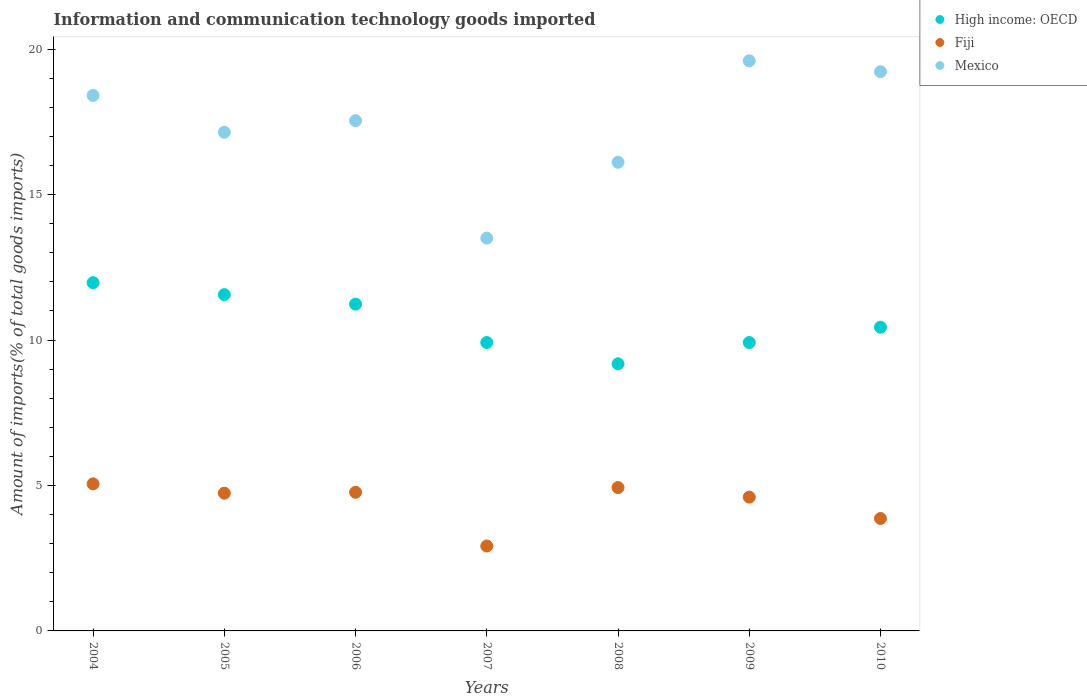Is the number of dotlines equal to the number of legend labels?
Provide a succinct answer. Yes. What is the amount of goods imported in High income: OECD in 2006?
Make the answer very short. 11.24. Across all years, what is the maximum amount of goods imported in Mexico?
Provide a short and direct response. 19.6. Across all years, what is the minimum amount of goods imported in Mexico?
Provide a succinct answer. 13.51. In which year was the amount of goods imported in Fiji maximum?
Your answer should be very brief. 2004. In which year was the amount of goods imported in Fiji minimum?
Give a very brief answer. 2007. What is the total amount of goods imported in High income: OECD in the graph?
Give a very brief answer. 74.23. What is the difference between the amount of goods imported in Mexico in 2005 and that in 2010?
Provide a succinct answer. -2.08. What is the difference between the amount of goods imported in High income: OECD in 2006 and the amount of goods imported in Mexico in 2008?
Your answer should be very brief. -4.88. What is the average amount of goods imported in Mexico per year?
Your answer should be very brief. 17.36. In the year 2007, what is the difference between the amount of goods imported in Fiji and amount of goods imported in High income: OECD?
Keep it short and to the point. -7. In how many years, is the amount of goods imported in High income: OECD greater than 18 %?
Keep it short and to the point. 0. What is the ratio of the amount of goods imported in Fiji in 2004 to that in 2009?
Give a very brief answer. 1.1. Is the difference between the amount of goods imported in Fiji in 2004 and 2010 greater than the difference between the amount of goods imported in High income: OECD in 2004 and 2010?
Ensure brevity in your answer.  No. What is the difference between the highest and the second highest amount of goods imported in Fiji?
Keep it short and to the point. 0.13. What is the difference between the highest and the lowest amount of goods imported in High income: OECD?
Ensure brevity in your answer.  2.79. In how many years, is the amount of goods imported in High income: OECD greater than the average amount of goods imported in High income: OECD taken over all years?
Offer a very short reply. 3. Is the sum of the amount of goods imported in Mexico in 2007 and 2009 greater than the maximum amount of goods imported in High income: OECD across all years?
Make the answer very short. Yes. Is it the case that in every year, the sum of the amount of goods imported in Fiji and amount of goods imported in High income: OECD  is greater than the amount of goods imported in Mexico?
Your answer should be compact. No. Is the amount of goods imported in Fiji strictly less than the amount of goods imported in Mexico over the years?
Your answer should be compact. Yes. Does the graph contain any zero values?
Keep it short and to the point. No. Where does the legend appear in the graph?
Offer a terse response. Top right. How many legend labels are there?
Make the answer very short. 3. How are the legend labels stacked?
Ensure brevity in your answer.  Vertical. What is the title of the graph?
Make the answer very short. Information and communication technology goods imported. What is the label or title of the Y-axis?
Provide a short and direct response. Amount of imports(% of total goods imports). What is the Amount of imports(% of total goods imports) in High income: OECD in 2004?
Your response must be concise. 11.97. What is the Amount of imports(% of total goods imports) of Fiji in 2004?
Your answer should be very brief. 5.06. What is the Amount of imports(% of total goods imports) of Mexico in 2004?
Give a very brief answer. 18.41. What is the Amount of imports(% of total goods imports) of High income: OECD in 2005?
Your answer should be very brief. 11.56. What is the Amount of imports(% of total goods imports) of Fiji in 2005?
Offer a terse response. 4.73. What is the Amount of imports(% of total goods imports) in Mexico in 2005?
Ensure brevity in your answer.  17.14. What is the Amount of imports(% of total goods imports) in High income: OECD in 2006?
Offer a very short reply. 11.24. What is the Amount of imports(% of total goods imports) in Fiji in 2006?
Offer a terse response. 4.77. What is the Amount of imports(% of total goods imports) in Mexico in 2006?
Your answer should be very brief. 17.54. What is the Amount of imports(% of total goods imports) in High income: OECD in 2007?
Provide a succinct answer. 9.92. What is the Amount of imports(% of total goods imports) of Fiji in 2007?
Offer a very short reply. 2.92. What is the Amount of imports(% of total goods imports) of Mexico in 2007?
Your answer should be compact. 13.51. What is the Amount of imports(% of total goods imports) in High income: OECD in 2008?
Provide a short and direct response. 9.18. What is the Amount of imports(% of total goods imports) in Fiji in 2008?
Your response must be concise. 4.93. What is the Amount of imports(% of total goods imports) of Mexico in 2008?
Provide a short and direct response. 16.11. What is the Amount of imports(% of total goods imports) in High income: OECD in 2009?
Your response must be concise. 9.92. What is the Amount of imports(% of total goods imports) of Fiji in 2009?
Provide a succinct answer. 4.6. What is the Amount of imports(% of total goods imports) of Mexico in 2009?
Keep it short and to the point. 19.6. What is the Amount of imports(% of total goods imports) of High income: OECD in 2010?
Make the answer very short. 10.44. What is the Amount of imports(% of total goods imports) in Fiji in 2010?
Your answer should be compact. 3.87. What is the Amount of imports(% of total goods imports) of Mexico in 2010?
Your answer should be very brief. 19.23. Across all years, what is the maximum Amount of imports(% of total goods imports) of High income: OECD?
Your response must be concise. 11.97. Across all years, what is the maximum Amount of imports(% of total goods imports) in Fiji?
Offer a terse response. 5.06. Across all years, what is the maximum Amount of imports(% of total goods imports) of Mexico?
Offer a terse response. 19.6. Across all years, what is the minimum Amount of imports(% of total goods imports) of High income: OECD?
Your response must be concise. 9.18. Across all years, what is the minimum Amount of imports(% of total goods imports) of Fiji?
Ensure brevity in your answer.  2.92. Across all years, what is the minimum Amount of imports(% of total goods imports) in Mexico?
Offer a very short reply. 13.51. What is the total Amount of imports(% of total goods imports) of High income: OECD in the graph?
Make the answer very short. 74.23. What is the total Amount of imports(% of total goods imports) of Fiji in the graph?
Your answer should be very brief. 30.87. What is the total Amount of imports(% of total goods imports) in Mexico in the graph?
Your answer should be compact. 121.54. What is the difference between the Amount of imports(% of total goods imports) in High income: OECD in 2004 and that in 2005?
Keep it short and to the point. 0.41. What is the difference between the Amount of imports(% of total goods imports) in Fiji in 2004 and that in 2005?
Your answer should be compact. 0.32. What is the difference between the Amount of imports(% of total goods imports) in Mexico in 2004 and that in 2005?
Ensure brevity in your answer.  1.27. What is the difference between the Amount of imports(% of total goods imports) in High income: OECD in 2004 and that in 2006?
Your answer should be compact. 0.74. What is the difference between the Amount of imports(% of total goods imports) in Fiji in 2004 and that in 2006?
Your answer should be compact. 0.29. What is the difference between the Amount of imports(% of total goods imports) of Mexico in 2004 and that in 2006?
Give a very brief answer. 0.87. What is the difference between the Amount of imports(% of total goods imports) in High income: OECD in 2004 and that in 2007?
Offer a terse response. 2.06. What is the difference between the Amount of imports(% of total goods imports) of Fiji in 2004 and that in 2007?
Your response must be concise. 2.14. What is the difference between the Amount of imports(% of total goods imports) in Mexico in 2004 and that in 2007?
Offer a very short reply. 4.9. What is the difference between the Amount of imports(% of total goods imports) of High income: OECD in 2004 and that in 2008?
Offer a very short reply. 2.79. What is the difference between the Amount of imports(% of total goods imports) in Fiji in 2004 and that in 2008?
Ensure brevity in your answer.  0.13. What is the difference between the Amount of imports(% of total goods imports) of Mexico in 2004 and that in 2008?
Make the answer very short. 2.3. What is the difference between the Amount of imports(% of total goods imports) of High income: OECD in 2004 and that in 2009?
Your response must be concise. 2.06. What is the difference between the Amount of imports(% of total goods imports) of Fiji in 2004 and that in 2009?
Your response must be concise. 0.46. What is the difference between the Amount of imports(% of total goods imports) of Mexico in 2004 and that in 2009?
Provide a short and direct response. -1.19. What is the difference between the Amount of imports(% of total goods imports) of High income: OECD in 2004 and that in 2010?
Offer a terse response. 1.53. What is the difference between the Amount of imports(% of total goods imports) in Fiji in 2004 and that in 2010?
Provide a short and direct response. 1.19. What is the difference between the Amount of imports(% of total goods imports) in Mexico in 2004 and that in 2010?
Offer a very short reply. -0.82. What is the difference between the Amount of imports(% of total goods imports) in High income: OECD in 2005 and that in 2006?
Offer a very short reply. 0.33. What is the difference between the Amount of imports(% of total goods imports) of Fiji in 2005 and that in 2006?
Make the answer very short. -0.03. What is the difference between the Amount of imports(% of total goods imports) of Mexico in 2005 and that in 2006?
Make the answer very short. -0.4. What is the difference between the Amount of imports(% of total goods imports) of High income: OECD in 2005 and that in 2007?
Make the answer very short. 1.65. What is the difference between the Amount of imports(% of total goods imports) in Fiji in 2005 and that in 2007?
Ensure brevity in your answer.  1.82. What is the difference between the Amount of imports(% of total goods imports) of Mexico in 2005 and that in 2007?
Give a very brief answer. 3.64. What is the difference between the Amount of imports(% of total goods imports) in High income: OECD in 2005 and that in 2008?
Ensure brevity in your answer.  2.38. What is the difference between the Amount of imports(% of total goods imports) in Fiji in 2005 and that in 2008?
Offer a terse response. -0.19. What is the difference between the Amount of imports(% of total goods imports) in Mexico in 2005 and that in 2008?
Give a very brief answer. 1.03. What is the difference between the Amount of imports(% of total goods imports) in High income: OECD in 2005 and that in 2009?
Keep it short and to the point. 1.65. What is the difference between the Amount of imports(% of total goods imports) of Fiji in 2005 and that in 2009?
Offer a terse response. 0.13. What is the difference between the Amount of imports(% of total goods imports) of Mexico in 2005 and that in 2009?
Your answer should be compact. -2.46. What is the difference between the Amount of imports(% of total goods imports) of High income: OECD in 2005 and that in 2010?
Offer a terse response. 1.12. What is the difference between the Amount of imports(% of total goods imports) of Fiji in 2005 and that in 2010?
Offer a very short reply. 0.87. What is the difference between the Amount of imports(% of total goods imports) of Mexico in 2005 and that in 2010?
Your response must be concise. -2.08. What is the difference between the Amount of imports(% of total goods imports) of High income: OECD in 2006 and that in 2007?
Keep it short and to the point. 1.32. What is the difference between the Amount of imports(% of total goods imports) in Fiji in 2006 and that in 2007?
Provide a succinct answer. 1.85. What is the difference between the Amount of imports(% of total goods imports) of Mexico in 2006 and that in 2007?
Offer a very short reply. 4.04. What is the difference between the Amount of imports(% of total goods imports) in High income: OECD in 2006 and that in 2008?
Offer a terse response. 2.05. What is the difference between the Amount of imports(% of total goods imports) of Fiji in 2006 and that in 2008?
Give a very brief answer. -0.16. What is the difference between the Amount of imports(% of total goods imports) in Mexico in 2006 and that in 2008?
Provide a short and direct response. 1.43. What is the difference between the Amount of imports(% of total goods imports) in High income: OECD in 2006 and that in 2009?
Your response must be concise. 1.32. What is the difference between the Amount of imports(% of total goods imports) in Fiji in 2006 and that in 2009?
Give a very brief answer. 0.17. What is the difference between the Amount of imports(% of total goods imports) in Mexico in 2006 and that in 2009?
Offer a very short reply. -2.06. What is the difference between the Amount of imports(% of total goods imports) of High income: OECD in 2006 and that in 2010?
Make the answer very short. 0.79. What is the difference between the Amount of imports(% of total goods imports) of Fiji in 2006 and that in 2010?
Your answer should be compact. 0.9. What is the difference between the Amount of imports(% of total goods imports) of Mexico in 2006 and that in 2010?
Your answer should be compact. -1.68. What is the difference between the Amount of imports(% of total goods imports) in High income: OECD in 2007 and that in 2008?
Ensure brevity in your answer.  0.73. What is the difference between the Amount of imports(% of total goods imports) of Fiji in 2007 and that in 2008?
Your answer should be very brief. -2.01. What is the difference between the Amount of imports(% of total goods imports) in Mexico in 2007 and that in 2008?
Give a very brief answer. -2.61. What is the difference between the Amount of imports(% of total goods imports) of High income: OECD in 2007 and that in 2009?
Give a very brief answer. 0. What is the difference between the Amount of imports(% of total goods imports) in Fiji in 2007 and that in 2009?
Ensure brevity in your answer.  -1.68. What is the difference between the Amount of imports(% of total goods imports) in Mexico in 2007 and that in 2009?
Make the answer very short. -6.09. What is the difference between the Amount of imports(% of total goods imports) in High income: OECD in 2007 and that in 2010?
Your response must be concise. -0.53. What is the difference between the Amount of imports(% of total goods imports) of Fiji in 2007 and that in 2010?
Ensure brevity in your answer.  -0.95. What is the difference between the Amount of imports(% of total goods imports) in Mexico in 2007 and that in 2010?
Offer a very short reply. -5.72. What is the difference between the Amount of imports(% of total goods imports) of High income: OECD in 2008 and that in 2009?
Ensure brevity in your answer.  -0.73. What is the difference between the Amount of imports(% of total goods imports) of Fiji in 2008 and that in 2009?
Offer a terse response. 0.33. What is the difference between the Amount of imports(% of total goods imports) of Mexico in 2008 and that in 2009?
Provide a succinct answer. -3.49. What is the difference between the Amount of imports(% of total goods imports) in High income: OECD in 2008 and that in 2010?
Provide a succinct answer. -1.26. What is the difference between the Amount of imports(% of total goods imports) in Fiji in 2008 and that in 2010?
Give a very brief answer. 1.06. What is the difference between the Amount of imports(% of total goods imports) of Mexico in 2008 and that in 2010?
Your response must be concise. -3.11. What is the difference between the Amount of imports(% of total goods imports) in High income: OECD in 2009 and that in 2010?
Your response must be concise. -0.53. What is the difference between the Amount of imports(% of total goods imports) of Fiji in 2009 and that in 2010?
Keep it short and to the point. 0.73. What is the difference between the Amount of imports(% of total goods imports) of Mexico in 2009 and that in 2010?
Offer a terse response. 0.37. What is the difference between the Amount of imports(% of total goods imports) of High income: OECD in 2004 and the Amount of imports(% of total goods imports) of Fiji in 2005?
Ensure brevity in your answer.  7.24. What is the difference between the Amount of imports(% of total goods imports) of High income: OECD in 2004 and the Amount of imports(% of total goods imports) of Mexico in 2005?
Your response must be concise. -5.17. What is the difference between the Amount of imports(% of total goods imports) in Fiji in 2004 and the Amount of imports(% of total goods imports) in Mexico in 2005?
Make the answer very short. -12.09. What is the difference between the Amount of imports(% of total goods imports) in High income: OECD in 2004 and the Amount of imports(% of total goods imports) in Fiji in 2006?
Provide a short and direct response. 7.21. What is the difference between the Amount of imports(% of total goods imports) of High income: OECD in 2004 and the Amount of imports(% of total goods imports) of Mexico in 2006?
Provide a short and direct response. -5.57. What is the difference between the Amount of imports(% of total goods imports) of Fiji in 2004 and the Amount of imports(% of total goods imports) of Mexico in 2006?
Offer a terse response. -12.49. What is the difference between the Amount of imports(% of total goods imports) in High income: OECD in 2004 and the Amount of imports(% of total goods imports) in Fiji in 2007?
Make the answer very short. 9.05. What is the difference between the Amount of imports(% of total goods imports) of High income: OECD in 2004 and the Amount of imports(% of total goods imports) of Mexico in 2007?
Keep it short and to the point. -1.53. What is the difference between the Amount of imports(% of total goods imports) of Fiji in 2004 and the Amount of imports(% of total goods imports) of Mexico in 2007?
Your response must be concise. -8.45. What is the difference between the Amount of imports(% of total goods imports) in High income: OECD in 2004 and the Amount of imports(% of total goods imports) in Fiji in 2008?
Provide a succinct answer. 7.04. What is the difference between the Amount of imports(% of total goods imports) of High income: OECD in 2004 and the Amount of imports(% of total goods imports) of Mexico in 2008?
Provide a short and direct response. -4.14. What is the difference between the Amount of imports(% of total goods imports) in Fiji in 2004 and the Amount of imports(% of total goods imports) in Mexico in 2008?
Provide a succinct answer. -11.06. What is the difference between the Amount of imports(% of total goods imports) in High income: OECD in 2004 and the Amount of imports(% of total goods imports) in Fiji in 2009?
Ensure brevity in your answer.  7.37. What is the difference between the Amount of imports(% of total goods imports) of High income: OECD in 2004 and the Amount of imports(% of total goods imports) of Mexico in 2009?
Keep it short and to the point. -7.63. What is the difference between the Amount of imports(% of total goods imports) of Fiji in 2004 and the Amount of imports(% of total goods imports) of Mexico in 2009?
Provide a short and direct response. -14.54. What is the difference between the Amount of imports(% of total goods imports) of High income: OECD in 2004 and the Amount of imports(% of total goods imports) of Fiji in 2010?
Ensure brevity in your answer.  8.11. What is the difference between the Amount of imports(% of total goods imports) in High income: OECD in 2004 and the Amount of imports(% of total goods imports) in Mexico in 2010?
Keep it short and to the point. -7.25. What is the difference between the Amount of imports(% of total goods imports) in Fiji in 2004 and the Amount of imports(% of total goods imports) in Mexico in 2010?
Your response must be concise. -14.17. What is the difference between the Amount of imports(% of total goods imports) of High income: OECD in 2005 and the Amount of imports(% of total goods imports) of Fiji in 2006?
Your response must be concise. 6.8. What is the difference between the Amount of imports(% of total goods imports) of High income: OECD in 2005 and the Amount of imports(% of total goods imports) of Mexico in 2006?
Give a very brief answer. -5.98. What is the difference between the Amount of imports(% of total goods imports) of Fiji in 2005 and the Amount of imports(% of total goods imports) of Mexico in 2006?
Ensure brevity in your answer.  -12.81. What is the difference between the Amount of imports(% of total goods imports) in High income: OECD in 2005 and the Amount of imports(% of total goods imports) in Fiji in 2007?
Provide a succinct answer. 8.64. What is the difference between the Amount of imports(% of total goods imports) of High income: OECD in 2005 and the Amount of imports(% of total goods imports) of Mexico in 2007?
Your response must be concise. -1.94. What is the difference between the Amount of imports(% of total goods imports) in Fiji in 2005 and the Amount of imports(% of total goods imports) in Mexico in 2007?
Provide a short and direct response. -8.77. What is the difference between the Amount of imports(% of total goods imports) in High income: OECD in 2005 and the Amount of imports(% of total goods imports) in Fiji in 2008?
Your answer should be very brief. 6.63. What is the difference between the Amount of imports(% of total goods imports) in High income: OECD in 2005 and the Amount of imports(% of total goods imports) in Mexico in 2008?
Your answer should be very brief. -4.55. What is the difference between the Amount of imports(% of total goods imports) of Fiji in 2005 and the Amount of imports(% of total goods imports) of Mexico in 2008?
Make the answer very short. -11.38. What is the difference between the Amount of imports(% of total goods imports) in High income: OECD in 2005 and the Amount of imports(% of total goods imports) in Fiji in 2009?
Make the answer very short. 6.96. What is the difference between the Amount of imports(% of total goods imports) in High income: OECD in 2005 and the Amount of imports(% of total goods imports) in Mexico in 2009?
Your answer should be compact. -8.04. What is the difference between the Amount of imports(% of total goods imports) in Fiji in 2005 and the Amount of imports(% of total goods imports) in Mexico in 2009?
Give a very brief answer. -14.86. What is the difference between the Amount of imports(% of total goods imports) of High income: OECD in 2005 and the Amount of imports(% of total goods imports) of Fiji in 2010?
Provide a succinct answer. 7.7. What is the difference between the Amount of imports(% of total goods imports) of High income: OECD in 2005 and the Amount of imports(% of total goods imports) of Mexico in 2010?
Provide a succinct answer. -7.66. What is the difference between the Amount of imports(% of total goods imports) of Fiji in 2005 and the Amount of imports(% of total goods imports) of Mexico in 2010?
Offer a very short reply. -14.49. What is the difference between the Amount of imports(% of total goods imports) in High income: OECD in 2006 and the Amount of imports(% of total goods imports) in Fiji in 2007?
Your answer should be compact. 8.32. What is the difference between the Amount of imports(% of total goods imports) of High income: OECD in 2006 and the Amount of imports(% of total goods imports) of Mexico in 2007?
Offer a terse response. -2.27. What is the difference between the Amount of imports(% of total goods imports) of Fiji in 2006 and the Amount of imports(% of total goods imports) of Mexico in 2007?
Offer a terse response. -8.74. What is the difference between the Amount of imports(% of total goods imports) of High income: OECD in 2006 and the Amount of imports(% of total goods imports) of Fiji in 2008?
Provide a short and direct response. 6.31. What is the difference between the Amount of imports(% of total goods imports) of High income: OECD in 2006 and the Amount of imports(% of total goods imports) of Mexico in 2008?
Offer a terse response. -4.88. What is the difference between the Amount of imports(% of total goods imports) in Fiji in 2006 and the Amount of imports(% of total goods imports) in Mexico in 2008?
Make the answer very short. -11.35. What is the difference between the Amount of imports(% of total goods imports) of High income: OECD in 2006 and the Amount of imports(% of total goods imports) of Fiji in 2009?
Provide a succinct answer. 6.63. What is the difference between the Amount of imports(% of total goods imports) of High income: OECD in 2006 and the Amount of imports(% of total goods imports) of Mexico in 2009?
Your answer should be compact. -8.36. What is the difference between the Amount of imports(% of total goods imports) of Fiji in 2006 and the Amount of imports(% of total goods imports) of Mexico in 2009?
Keep it short and to the point. -14.83. What is the difference between the Amount of imports(% of total goods imports) of High income: OECD in 2006 and the Amount of imports(% of total goods imports) of Fiji in 2010?
Keep it short and to the point. 7.37. What is the difference between the Amount of imports(% of total goods imports) of High income: OECD in 2006 and the Amount of imports(% of total goods imports) of Mexico in 2010?
Your response must be concise. -7.99. What is the difference between the Amount of imports(% of total goods imports) of Fiji in 2006 and the Amount of imports(% of total goods imports) of Mexico in 2010?
Give a very brief answer. -14.46. What is the difference between the Amount of imports(% of total goods imports) in High income: OECD in 2007 and the Amount of imports(% of total goods imports) in Fiji in 2008?
Your response must be concise. 4.99. What is the difference between the Amount of imports(% of total goods imports) of High income: OECD in 2007 and the Amount of imports(% of total goods imports) of Mexico in 2008?
Give a very brief answer. -6.2. What is the difference between the Amount of imports(% of total goods imports) in Fiji in 2007 and the Amount of imports(% of total goods imports) in Mexico in 2008?
Provide a succinct answer. -13.19. What is the difference between the Amount of imports(% of total goods imports) in High income: OECD in 2007 and the Amount of imports(% of total goods imports) in Fiji in 2009?
Your answer should be compact. 5.32. What is the difference between the Amount of imports(% of total goods imports) of High income: OECD in 2007 and the Amount of imports(% of total goods imports) of Mexico in 2009?
Your answer should be compact. -9.68. What is the difference between the Amount of imports(% of total goods imports) in Fiji in 2007 and the Amount of imports(% of total goods imports) in Mexico in 2009?
Your answer should be compact. -16.68. What is the difference between the Amount of imports(% of total goods imports) in High income: OECD in 2007 and the Amount of imports(% of total goods imports) in Fiji in 2010?
Your answer should be very brief. 6.05. What is the difference between the Amount of imports(% of total goods imports) in High income: OECD in 2007 and the Amount of imports(% of total goods imports) in Mexico in 2010?
Your answer should be very brief. -9.31. What is the difference between the Amount of imports(% of total goods imports) in Fiji in 2007 and the Amount of imports(% of total goods imports) in Mexico in 2010?
Your response must be concise. -16.31. What is the difference between the Amount of imports(% of total goods imports) in High income: OECD in 2008 and the Amount of imports(% of total goods imports) in Fiji in 2009?
Your answer should be very brief. 4.58. What is the difference between the Amount of imports(% of total goods imports) in High income: OECD in 2008 and the Amount of imports(% of total goods imports) in Mexico in 2009?
Your answer should be very brief. -10.42. What is the difference between the Amount of imports(% of total goods imports) in Fiji in 2008 and the Amount of imports(% of total goods imports) in Mexico in 2009?
Your answer should be very brief. -14.67. What is the difference between the Amount of imports(% of total goods imports) of High income: OECD in 2008 and the Amount of imports(% of total goods imports) of Fiji in 2010?
Provide a short and direct response. 5.32. What is the difference between the Amount of imports(% of total goods imports) in High income: OECD in 2008 and the Amount of imports(% of total goods imports) in Mexico in 2010?
Give a very brief answer. -10.04. What is the difference between the Amount of imports(% of total goods imports) of Fiji in 2008 and the Amount of imports(% of total goods imports) of Mexico in 2010?
Give a very brief answer. -14.3. What is the difference between the Amount of imports(% of total goods imports) in High income: OECD in 2009 and the Amount of imports(% of total goods imports) in Fiji in 2010?
Make the answer very short. 6.05. What is the difference between the Amount of imports(% of total goods imports) of High income: OECD in 2009 and the Amount of imports(% of total goods imports) of Mexico in 2010?
Ensure brevity in your answer.  -9.31. What is the difference between the Amount of imports(% of total goods imports) in Fiji in 2009 and the Amount of imports(% of total goods imports) in Mexico in 2010?
Ensure brevity in your answer.  -14.63. What is the average Amount of imports(% of total goods imports) of High income: OECD per year?
Offer a very short reply. 10.6. What is the average Amount of imports(% of total goods imports) in Fiji per year?
Offer a terse response. 4.41. What is the average Amount of imports(% of total goods imports) in Mexico per year?
Keep it short and to the point. 17.36. In the year 2004, what is the difference between the Amount of imports(% of total goods imports) in High income: OECD and Amount of imports(% of total goods imports) in Fiji?
Provide a succinct answer. 6.92. In the year 2004, what is the difference between the Amount of imports(% of total goods imports) of High income: OECD and Amount of imports(% of total goods imports) of Mexico?
Your answer should be very brief. -6.44. In the year 2004, what is the difference between the Amount of imports(% of total goods imports) of Fiji and Amount of imports(% of total goods imports) of Mexico?
Your response must be concise. -13.35. In the year 2005, what is the difference between the Amount of imports(% of total goods imports) in High income: OECD and Amount of imports(% of total goods imports) in Fiji?
Provide a succinct answer. 6.83. In the year 2005, what is the difference between the Amount of imports(% of total goods imports) of High income: OECD and Amount of imports(% of total goods imports) of Mexico?
Ensure brevity in your answer.  -5.58. In the year 2005, what is the difference between the Amount of imports(% of total goods imports) of Fiji and Amount of imports(% of total goods imports) of Mexico?
Offer a very short reply. -12.41. In the year 2006, what is the difference between the Amount of imports(% of total goods imports) in High income: OECD and Amount of imports(% of total goods imports) in Fiji?
Keep it short and to the point. 6.47. In the year 2006, what is the difference between the Amount of imports(% of total goods imports) in High income: OECD and Amount of imports(% of total goods imports) in Mexico?
Offer a very short reply. -6.31. In the year 2006, what is the difference between the Amount of imports(% of total goods imports) of Fiji and Amount of imports(% of total goods imports) of Mexico?
Ensure brevity in your answer.  -12.78. In the year 2007, what is the difference between the Amount of imports(% of total goods imports) in High income: OECD and Amount of imports(% of total goods imports) in Fiji?
Provide a succinct answer. 7. In the year 2007, what is the difference between the Amount of imports(% of total goods imports) of High income: OECD and Amount of imports(% of total goods imports) of Mexico?
Your response must be concise. -3.59. In the year 2007, what is the difference between the Amount of imports(% of total goods imports) of Fiji and Amount of imports(% of total goods imports) of Mexico?
Your response must be concise. -10.59. In the year 2008, what is the difference between the Amount of imports(% of total goods imports) in High income: OECD and Amount of imports(% of total goods imports) in Fiji?
Offer a terse response. 4.25. In the year 2008, what is the difference between the Amount of imports(% of total goods imports) of High income: OECD and Amount of imports(% of total goods imports) of Mexico?
Make the answer very short. -6.93. In the year 2008, what is the difference between the Amount of imports(% of total goods imports) in Fiji and Amount of imports(% of total goods imports) in Mexico?
Give a very brief answer. -11.18. In the year 2009, what is the difference between the Amount of imports(% of total goods imports) of High income: OECD and Amount of imports(% of total goods imports) of Fiji?
Ensure brevity in your answer.  5.32. In the year 2009, what is the difference between the Amount of imports(% of total goods imports) of High income: OECD and Amount of imports(% of total goods imports) of Mexico?
Your answer should be very brief. -9.68. In the year 2009, what is the difference between the Amount of imports(% of total goods imports) of Fiji and Amount of imports(% of total goods imports) of Mexico?
Your response must be concise. -15. In the year 2010, what is the difference between the Amount of imports(% of total goods imports) in High income: OECD and Amount of imports(% of total goods imports) in Fiji?
Your answer should be very brief. 6.58. In the year 2010, what is the difference between the Amount of imports(% of total goods imports) in High income: OECD and Amount of imports(% of total goods imports) in Mexico?
Provide a succinct answer. -8.78. In the year 2010, what is the difference between the Amount of imports(% of total goods imports) of Fiji and Amount of imports(% of total goods imports) of Mexico?
Offer a very short reply. -15.36. What is the ratio of the Amount of imports(% of total goods imports) of High income: OECD in 2004 to that in 2005?
Offer a terse response. 1.04. What is the ratio of the Amount of imports(% of total goods imports) in Fiji in 2004 to that in 2005?
Offer a very short reply. 1.07. What is the ratio of the Amount of imports(% of total goods imports) in Mexico in 2004 to that in 2005?
Offer a terse response. 1.07. What is the ratio of the Amount of imports(% of total goods imports) in High income: OECD in 2004 to that in 2006?
Your response must be concise. 1.07. What is the ratio of the Amount of imports(% of total goods imports) of Fiji in 2004 to that in 2006?
Give a very brief answer. 1.06. What is the ratio of the Amount of imports(% of total goods imports) in Mexico in 2004 to that in 2006?
Offer a terse response. 1.05. What is the ratio of the Amount of imports(% of total goods imports) of High income: OECD in 2004 to that in 2007?
Your answer should be compact. 1.21. What is the ratio of the Amount of imports(% of total goods imports) of Fiji in 2004 to that in 2007?
Ensure brevity in your answer.  1.73. What is the ratio of the Amount of imports(% of total goods imports) in Mexico in 2004 to that in 2007?
Ensure brevity in your answer.  1.36. What is the ratio of the Amount of imports(% of total goods imports) in High income: OECD in 2004 to that in 2008?
Your answer should be compact. 1.3. What is the ratio of the Amount of imports(% of total goods imports) of Fiji in 2004 to that in 2008?
Your answer should be very brief. 1.03. What is the ratio of the Amount of imports(% of total goods imports) of Mexico in 2004 to that in 2008?
Offer a very short reply. 1.14. What is the ratio of the Amount of imports(% of total goods imports) in High income: OECD in 2004 to that in 2009?
Give a very brief answer. 1.21. What is the ratio of the Amount of imports(% of total goods imports) of Fiji in 2004 to that in 2009?
Offer a terse response. 1.1. What is the ratio of the Amount of imports(% of total goods imports) in Mexico in 2004 to that in 2009?
Your response must be concise. 0.94. What is the ratio of the Amount of imports(% of total goods imports) of High income: OECD in 2004 to that in 2010?
Provide a succinct answer. 1.15. What is the ratio of the Amount of imports(% of total goods imports) of Fiji in 2004 to that in 2010?
Provide a succinct answer. 1.31. What is the ratio of the Amount of imports(% of total goods imports) in Mexico in 2004 to that in 2010?
Make the answer very short. 0.96. What is the ratio of the Amount of imports(% of total goods imports) of High income: OECD in 2005 to that in 2006?
Provide a succinct answer. 1.03. What is the ratio of the Amount of imports(% of total goods imports) of Fiji in 2005 to that in 2006?
Give a very brief answer. 0.99. What is the ratio of the Amount of imports(% of total goods imports) of Mexico in 2005 to that in 2006?
Provide a succinct answer. 0.98. What is the ratio of the Amount of imports(% of total goods imports) in High income: OECD in 2005 to that in 2007?
Offer a very short reply. 1.17. What is the ratio of the Amount of imports(% of total goods imports) in Fiji in 2005 to that in 2007?
Provide a succinct answer. 1.62. What is the ratio of the Amount of imports(% of total goods imports) of Mexico in 2005 to that in 2007?
Make the answer very short. 1.27. What is the ratio of the Amount of imports(% of total goods imports) in High income: OECD in 2005 to that in 2008?
Give a very brief answer. 1.26. What is the ratio of the Amount of imports(% of total goods imports) of Fiji in 2005 to that in 2008?
Give a very brief answer. 0.96. What is the ratio of the Amount of imports(% of total goods imports) of Mexico in 2005 to that in 2008?
Provide a short and direct response. 1.06. What is the ratio of the Amount of imports(% of total goods imports) of High income: OECD in 2005 to that in 2009?
Provide a succinct answer. 1.17. What is the ratio of the Amount of imports(% of total goods imports) in Fiji in 2005 to that in 2009?
Give a very brief answer. 1.03. What is the ratio of the Amount of imports(% of total goods imports) in Mexico in 2005 to that in 2009?
Keep it short and to the point. 0.87. What is the ratio of the Amount of imports(% of total goods imports) in High income: OECD in 2005 to that in 2010?
Your answer should be compact. 1.11. What is the ratio of the Amount of imports(% of total goods imports) in Fiji in 2005 to that in 2010?
Keep it short and to the point. 1.22. What is the ratio of the Amount of imports(% of total goods imports) in Mexico in 2005 to that in 2010?
Your answer should be compact. 0.89. What is the ratio of the Amount of imports(% of total goods imports) in High income: OECD in 2006 to that in 2007?
Provide a short and direct response. 1.13. What is the ratio of the Amount of imports(% of total goods imports) of Fiji in 2006 to that in 2007?
Ensure brevity in your answer.  1.63. What is the ratio of the Amount of imports(% of total goods imports) of Mexico in 2006 to that in 2007?
Provide a short and direct response. 1.3. What is the ratio of the Amount of imports(% of total goods imports) in High income: OECD in 2006 to that in 2008?
Offer a terse response. 1.22. What is the ratio of the Amount of imports(% of total goods imports) of Fiji in 2006 to that in 2008?
Offer a terse response. 0.97. What is the ratio of the Amount of imports(% of total goods imports) in Mexico in 2006 to that in 2008?
Your answer should be compact. 1.09. What is the ratio of the Amount of imports(% of total goods imports) of High income: OECD in 2006 to that in 2009?
Offer a very short reply. 1.13. What is the ratio of the Amount of imports(% of total goods imports) in Fiji in 2006 to that in 2009?
Keep it short and to the point. 1.04. What is the ratio of the Amount of imports(% of total goods imports) in Mexico in 2006 to that in 2009?
Give a very brief answer. 0.9. What is the ratio of the Amount of imports(% of total goods imports) in High income: OECD in 2006 to that in 2010?
Offer a terse response. 1.08. What is the ratio of the Amount of imports(% of total goods imports) of Fiji in 2006 to that in 2010?
Your answer should be compact. 1.23. What is the ratio of the Amount of imports(% of total goods imports) of Mexico in 2006 to that in 2010?
Give a very brief answer. 0.91. What is the ratio of the Amount of imports(% of total goods imports) of High income: OECD in 2007 to that in 2008?
Provide a short and direct response. 1.08. What is the ratio of the Amount of imports(% of total goods imports) of Fiji in 2007 to that in 2008?
Offer a very short reply. 0.59. What is the ratio of the Amount of imports(% of total goods imports) in Mexico in 2007 to that in 2008?
Your response must be concise. 0.84. What is the ratio of the Amount of imports(% of total goods imports) in High income: OECD in 2007 to that in 2009?
Your answer should be very brief. 1. What is the ratio of the Amount of imports(% of total goods imports) in Fiji in 2007 to that in 2009?
Make the answer very short. 0.63. What is the ratio of the Amount of imports(% of total goods imports) of Mexico in 2007 to that in 2009?
Make the answer very short. 0.69. What is the ratio of the Amount of imports(% of total goods imports) of High income: OECD in 2007 to that in 2010?
Make the answer very short. 0.95. What is the ratio of the Amount of imports(% of total goods imports) in Fiji in 2007 to that in 2010?
Make the answer very short. 0.76. What is the ratio of the Amount of imports(% of total goods imports) of Mexico in 2007 to that in 2010?
Your response must be concise. 0.7. What is the ratio of the Amount of imports(% of total goods imports) of High income: OECD in 2008 to that in 2009?
Your answer should be very brief. 0.93. What is the ratio of the Amount of imports(% of total goods imports) in Fiji in 2008 to that in 2009?
Keep it short and to the point. 1.07. What is the ratio of the Amount of imports(% of total goods imports) in Mexico in 2008 to that in 2009?
Keep it short and to the point. 0.82. What is the ratio of the Amount of imports(% of total goods imports) in High income: OECD in 2008 to that in 2010?
Ensure brevity in your answer.  0.88. What is the ratio of the Amount of imports(% of total goods imports) of Fiji in 2008 to that in 2010?
Provide a short and direct response. 1.27. What is the ratio of the Amount of imports(% of total goods imports) in Mexico in 2008 to that in 2010?
Give a very brief answer. 0.84. What is the ratio of the Amount of imports(% of total goods imports) in High income: OECD in 2009 to that in 2010?
Ensure brevity in your answer.  0.95. What is the ratio of the Amount of imports(% of total goods imports) of Fiji in 2009 to that in 2010?
Provide a short and direct response. 1.19. What is the ratio of the Amount of imports(% of total goods imports) of Mexico in 2009 to that in 2010?
Your answer should be compact. 1.02. What is the difference between the highest and the second highest Amount of imports(% of total goods imports) of High income: OECD?
Give a very brief answer. 0.41. What is the difference between the highest and the second highest Amount of imports(% of total goods imports) of Fiji?
Your answer should be very brief. 0.13. What is the difference between the highest and the second highest Amount of imports(% of total goods imports) of Mexico?
Provide a succinct answer. 0.37. What is the difference between the highest and the lowest Amount of imports(% of total goods imports) in High income: OECD?
Provide a short and direct response. 2.79. What is the difference between the highest and the lowest Amount of imports(% of total goods imports) of Fiji?
Offer a very short reply. 2.14. What is the difference between the highest and the lowest Amount of imports(% of total goods imports) in Mexico?
Your answer should be compact. 6.09. 